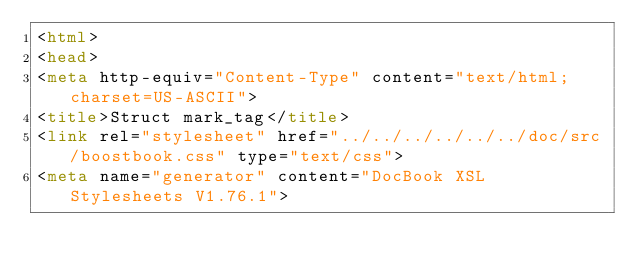<code> <loc_0><loc_0><loc_500><loc_500><_HTML_><html>
<head>
<meta http-equiv="Content-Type" content="text/html; charset=US-ASCII">
<title>Struct mark_tag</title>
<link rel="stylesheet" href="../../../../../../doc/src/boostbook.css" type="text/css">
<meta name="generator" content="DocBook XSL Stylesheets V1.76.1"></code> 